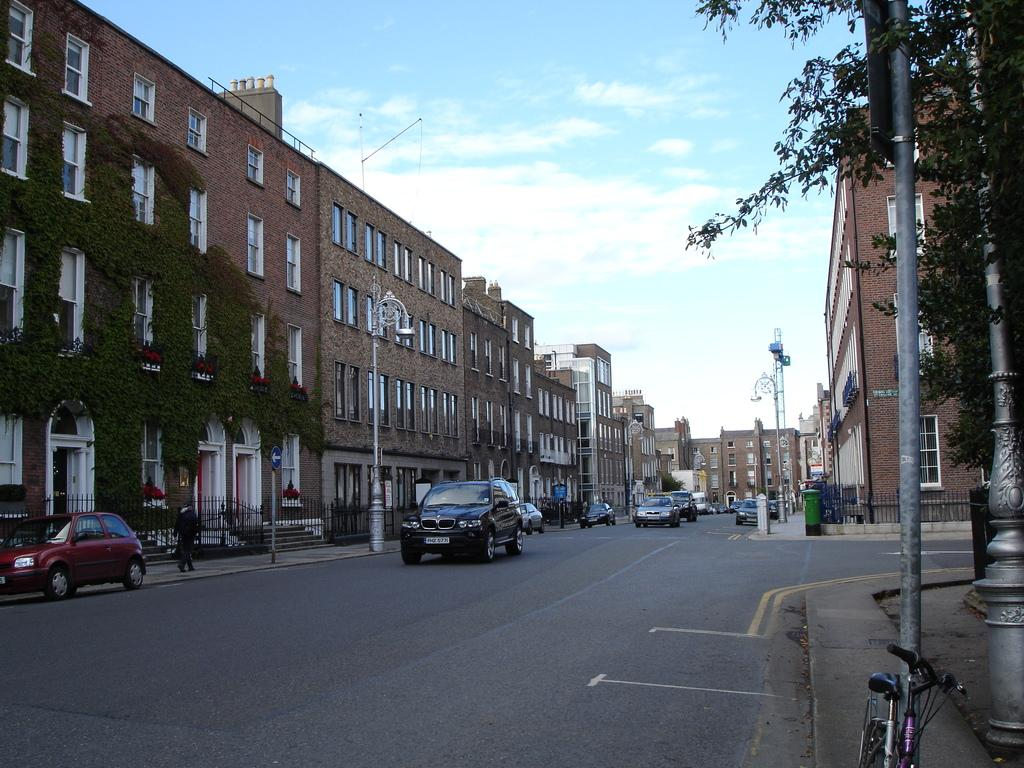What type of structures can be seen in the image? There are buildings in the image. What type of vehicles are present in the image? There are cars in the image. Are there any living beings visible in the image? Yes, there are people in the image. What type of natural elements can be seen in the image? There are trees and plants in the image. What type of man-made objects can be seen in the image? There are poles in the image. What type of pathway is visible in the image? There is a road in the image. What type of transportation is present in the image? There is a cycle in the image. Is there any pole associated with the cycle? Yes, there is a pole associated with the cycle. What part of the natural environment is visible in the image? The sky is visible in the image. What type of weather can be inferred from the image? The presence of clouds in the sky suggests that it might be partly cloudy. What type of underwear is the person wearing in the image? There is no information about the person's underwear in the image. What do you believe the people in the image are discussing? We cannot determine what the people in the image are discussing, as there is no information about their conversation. 